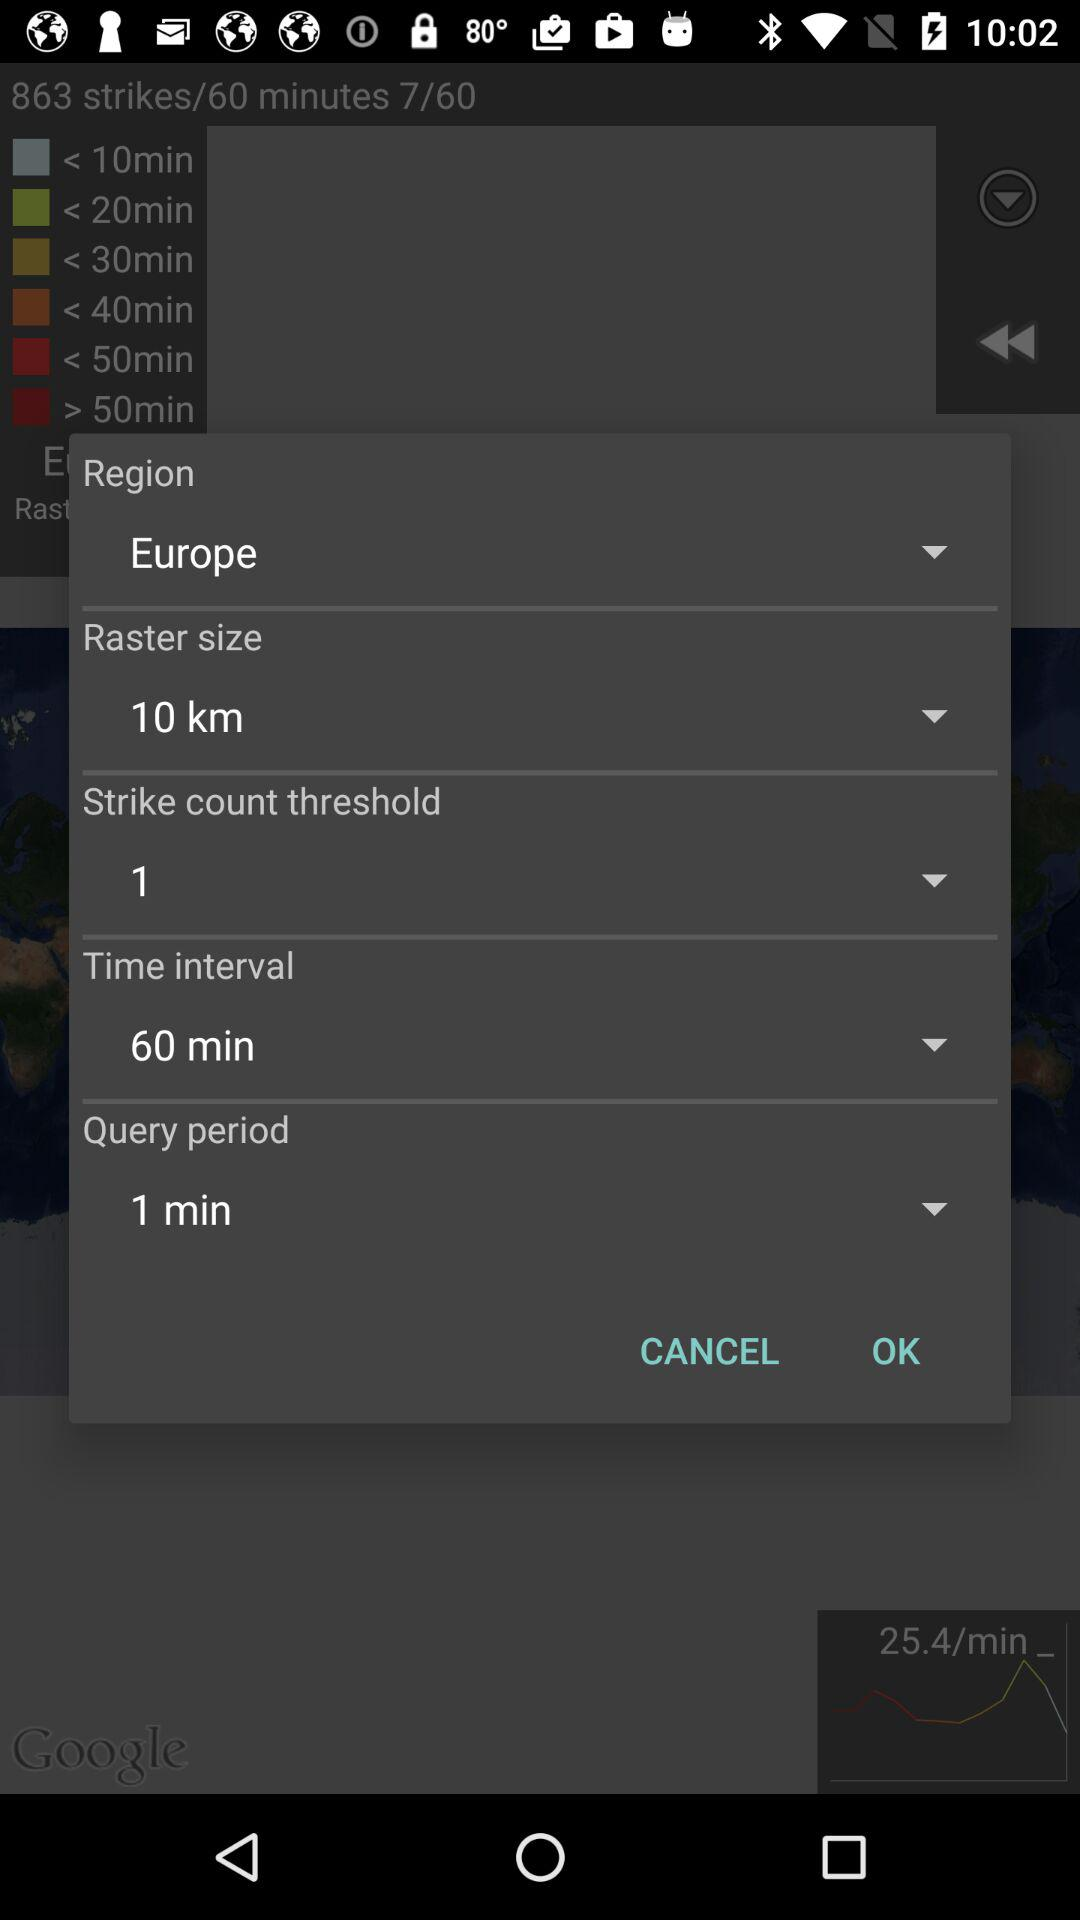How many strike count thresholds are selected? The selected strike count threshold is 1. 